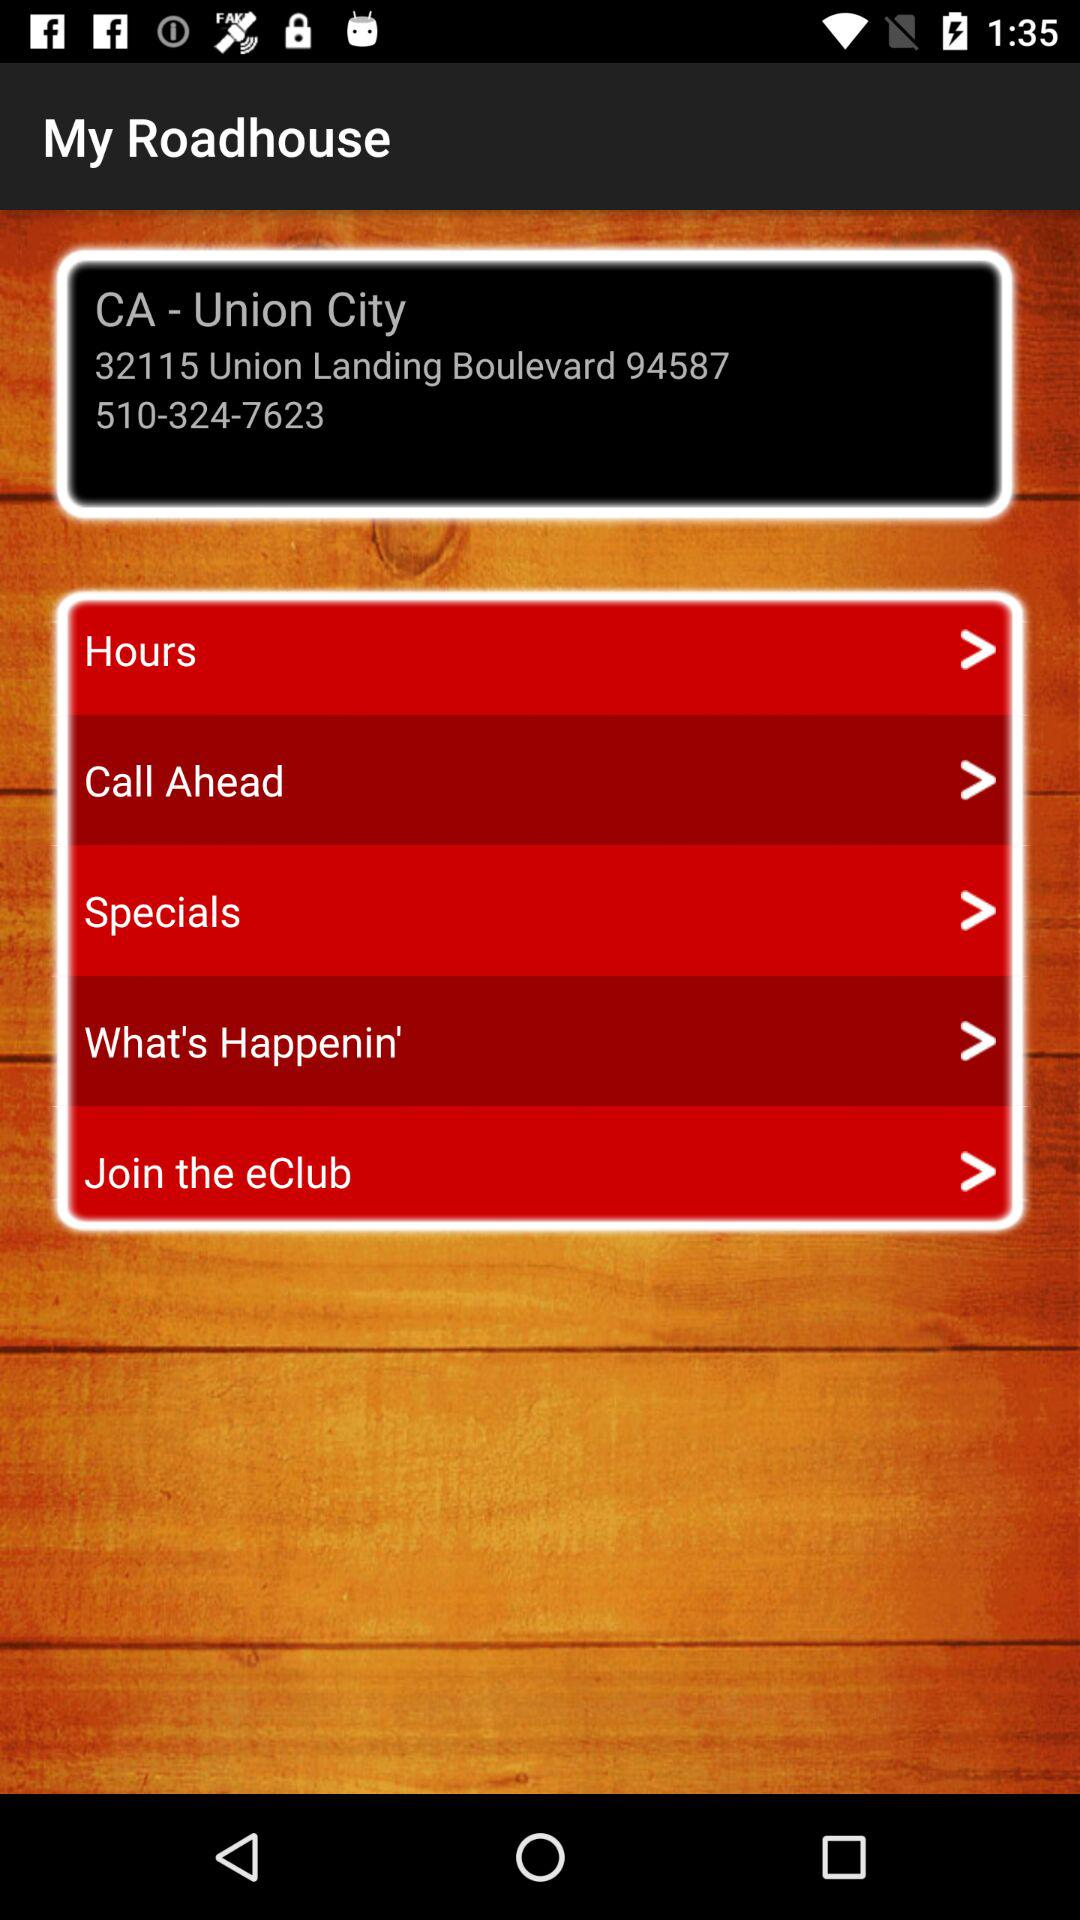What are the options available in the list? The available options are "Hours", "Call Ahead", "Specials", "What's Happenin'" and "Join the eClub". 